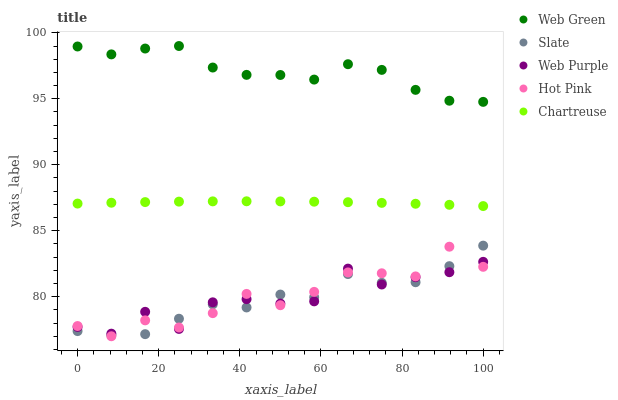Does Slate have the minimum area under the curve?
Answer yes or no. Yes. Does Web Green have the maximum area under the curve?
Answer yes or no. Yes. Does Hot Pink have the minimum area under the curve?
Answer yes or no. No. Does Hot Pink have the maximum area under the curve?
Answer yes or no. No. Is Chartreuse the smoothest?
Answer yes or no. Yes. Is Web Purple the roughest?
Answer yes or no. Yes. Is Slate the smoothest?
Answer yes or no. No. Is Slate the roughest?
Answer yes or no. No. Does Hot Pink have the lowest value?
Answer yes or no. Yes. Does Slate have the lowest value?
Answer yes or no. No. Does Web Green have the highest value?
Answer yes or no. Yes. Does Slate have the highest value?
Answer yes or no. No. Is Web Purple less than Web Green?
Answer yes or no. Yes. Is Chartreuse greater than Web Purple?
Answer yes or no. Yes. Does Web Purple intersect Hot Pink?
Answer yes or no. Yes. Is Web Purple less than Hot Pink?
Answer yes or no. No. Is Web Purple greater than Hot Pink?
Answer yes or no. No. Does Web Purple intersect Web Green?
Answer yes or no. No. 